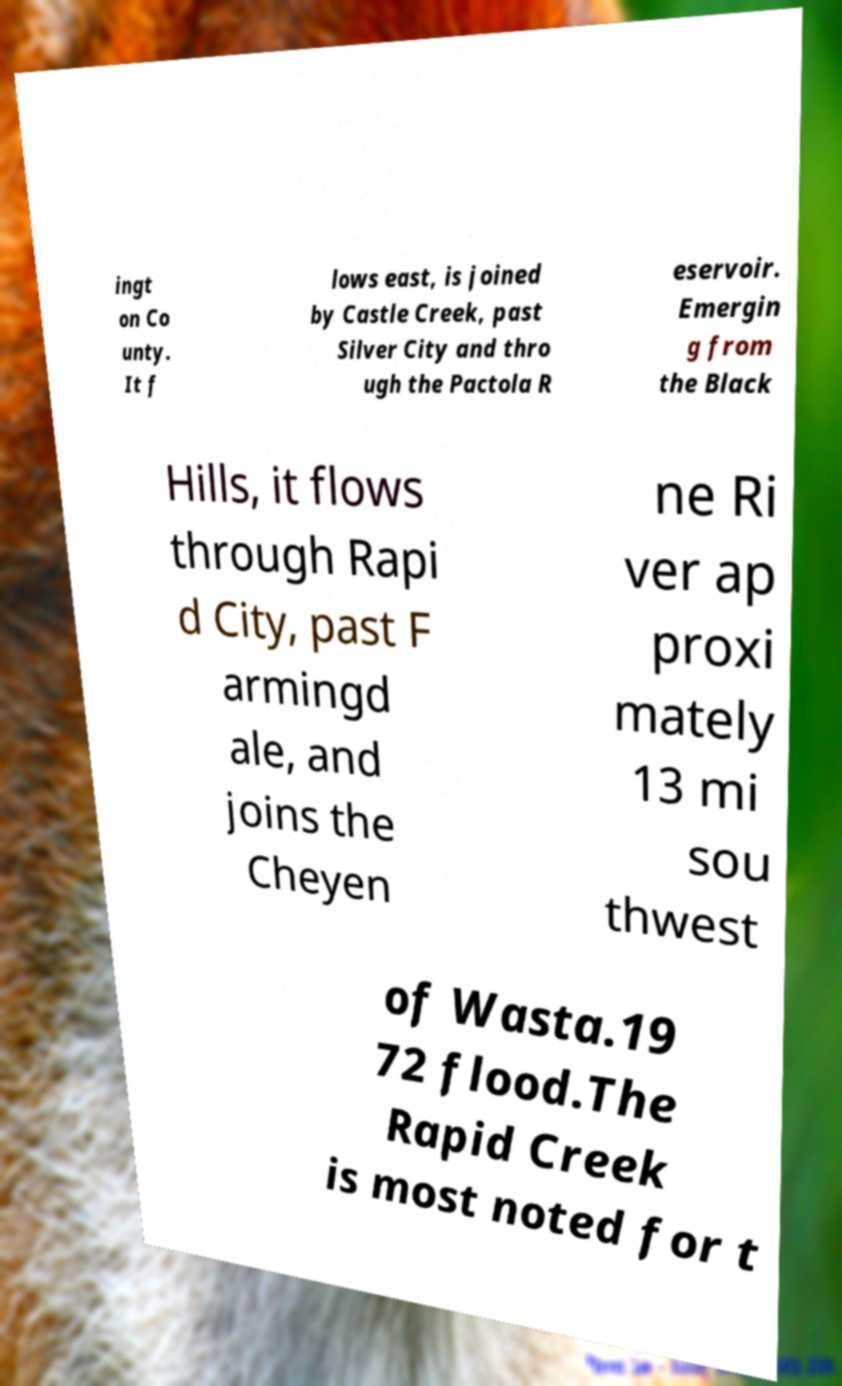Please read and relay the text visible in this image. What does it say? ingt on Co unty. It f lows east, is joined by Castle Creek, past Silver City and thro ugh the Pactola R eservoir. Emergin g from the Black Hills, it flows through Rapi d City, past F armingd ale, and joins the Cheyen ne Ri ver ap proxi mately 13 mi sou thwest of Wasta.19 72 flood.The Rapid Creek is most noted for t 